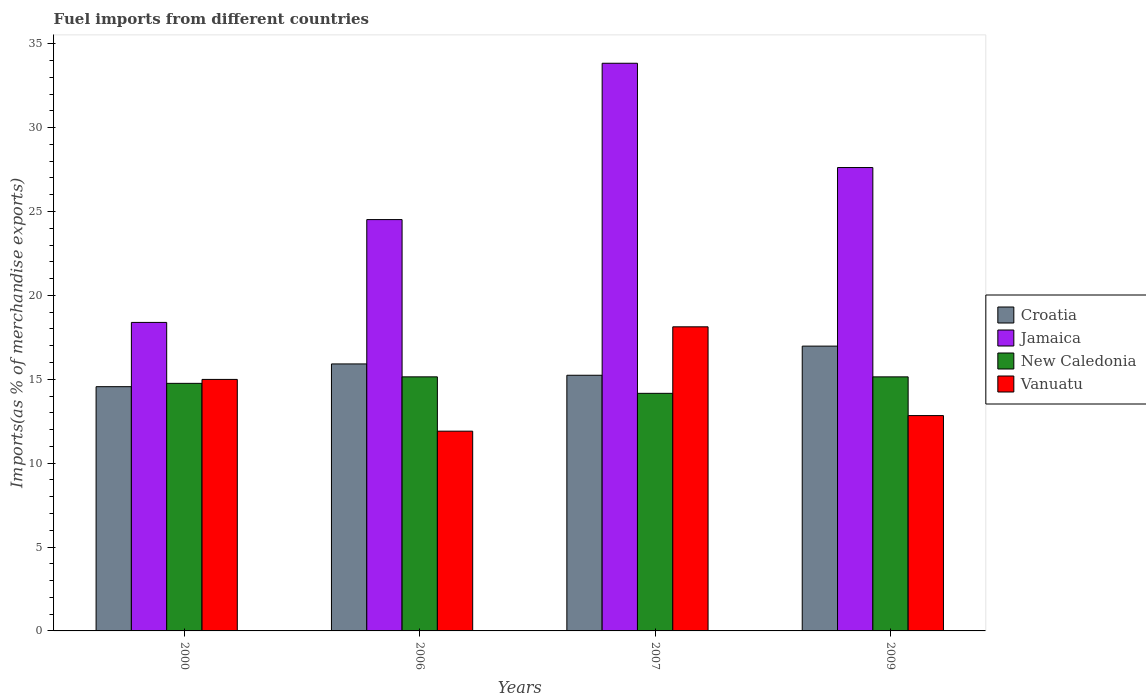How many groups of bars are there?
Provide a short and direct response. 4. Are the number of bars on each tick of the X-axis equal?
Offer a terse response. Yes. How many bars are there on the 2nd tick from the left?
Provide a succinct answer. 4. How many bars are there on the 2nd tick from the right?
Make the answer very short. 4. In how many cases, is the number of bars for a given year not equal to the number of legend labels?
Your answer should be very brief. 0. What is the percentage of imports to different countries in Vanuatu in 2007?
Keep it short and to the point. 18.13. Across all years, what is the maximum percentage of imports to different countries in Croatia?
Make the answer very short. 16.98. Across all years, what is the minimum percentage of imports to different countries in Vanuatu?
Provide a succinct answer. 11.91. In which year was the percentage of imports to different countries in Vanuatu maximum?
Give a very brief answer. 2007. In which year was the percentage of imports to different countries in Vanuatu minimum?
Your answer should be very brief. 2006. What is the total percentage of imports to different countries in Croatia in the graph?
Offer a terse response. 62.69. What is the difference between the percentage of imports to different countries in Jamaica in 2000 and that in 2009?
Provide a succinct answer. -9.23. What is the difference between the percentage of imports to different countries in New Caledonia in 2007 and the percentage of imports to different countries in Vanuatu in 2009?
Your answer should be very brief. 1.33. What is the average percentage of imports to different countries in Croatia per year?
Give a very brief answer. 15.67. In the year 2000, what is the difference between the percentage of imports to different countries in Vanuatu and percentage of imports to different countries in New Caledonia?
Your answer should be compact. 0.23. In how many years, is the percentage of imports to different countries in Jamaica greater than 14 %?
Offer a very short reply. 4. What is the ratio of the percentage of imports to different countries in Vanuatu in 2000 to that in 2009?
Make the answer very short. 1.17. Is the percentage of imports to different countries in Vanuatu in 2000 less than that in 2006?
Offer a very short reply. No. Is the difference between the percentage of imports to different countries in Vanuatu in 2006 and 2007 greater than the difference between the percentage of imports to different countries in New Caledonia in 2006 and 2007?
Offer a terse response. No. What is the difference between the highest and the second highest percentage of imports to different countries in Croatia?
Your response must be concise. 1.06. What is the difference between the highest and the lowest percentage of imports to different countries in New Caledonia?
Your answer should be very brief. 0.98. In how many years, is the percentage of imports to different countries in Jamaica greater than the average percentage of imports to different countries in Jamaica taken over all years?
Provide a short and direct response. 2. Is the sum of the percentage of imports to different countries in New Caledonia in 2000 and 2009 greater than the maximum percentage of imports to different countries in Jamaica across all years?
Your answer should be compact. No. What does the 1st bar from the left in 2000 represents?
Ensure brevity in your answer.  Croatia. What does the 2nd bar from the right in 2007 represents?
Ensure brevity in your answer.  New Caledonia. Is it the case that in every year, the sum of the percentage of imports to different countries in Croatia and percentage of imports to different countries in New Caledonia is greater than the percentage of imports to different countries in Jamaica?
Offer a very short reply. No. How many bars are there?
Keep it short and to the point. 16. Are all the bars in the graph horizontal?
Your answer should be compact. No. Does the graph contain grids?
Your answer should be compact. No. Where does the legend appear in the graph?
Keep it short and to the point. Center right. How many legend labels are there?
Offer a very short reply. 4. What is the title of the graph?
Your response must be concise. Fuel imports from different countries. Does "Gabon" appear as one of the legend labels in the graph?
Keep it short and to the point. No. What is the label or title of the Y-axis?
Ensure brevity in your answer.  Imports(as % of merchandise exports). What is the Imports(as % of merchandise exports) in Croatia in 2000?
Offer a terse response. 14.56. What is the Imports(as % of merchandise exports) in Jamaica in 2000?
Provide a succinct answer. 18.39. What is the Imports(as % of merchandise exports) of New Caledonia in 2000?
Your response must be concise. 14.76. What is the Imports(as % of merchandise exports) of Vanuatu in 2000?
Keep it short and to the point. 14.99. What is the Imports(as % of merchandise exports) in Croatia in 2006?
Provide a short and direct response. 15.92. What is the Imports(as % of merchandise exports) of Jamaica in 2006?
Give a very brief answer. 24.52. What is the Imports(as % of merchandise exports) in New Caledonia in 2006?
Offer a terse response. 15.15. What is the Imports(as % of merchandise exports) of Vanuatu in 2006?
Your answer should be compact. 11.91. What is the Imports(as % of merchandise exports) of Croatia in 2007?
Your answer should be compact. 15.24. What is the Imports(as % of merchandise exports) of Jamaica in 2007?
Provide a short and direct response. 33.84. What is the Imports(as % of merchandise exports) of New Caledonia in 2007?
Provide a succinct answer. 14.16. What is the Imports(as % of merchandise exports) of Vanuatu in 2007?
Provide a short and direct response. 18.13. What is the Imports(as % of merchandise exports) of Croatia in 2009?
Your answer should be very brief. 16.98. What is the Imports(as % of merchandise exports) in Jamaica in 2009?
Provide a short and direct response. 27.62. What is the Imports(as % of merchandise exports) in New Caledonia in 2009?
Your response must be concise. 15.14. What is the Imports(as % of merchandise exports) in Vanuatu in 2009?
Offer a terse response. 12.84. Across all years, what is the maximum Imports(as % of merchandise exports) of Croatia?
Keep it short and to the point. 16.98. Across all years, what is the maximum Imports(as % of merchandise exports) of Jamaica?
Your response must be concise. 33.84. Across all years, what is the maximum Imports(as % of merchandise exports) of New Caledonia?
Provide a short and direct response. 15.15. Across all years, what is the maximum Imports(as % of merchandise exports) of Vanuatu?
Offer a very short reply. 18.13. Across all years, what is the minimum Imports(as % of merchandise exports) in Croatia?
Give a very brief answer. 14.56. Across all years, what is the minimum Imports(as % of merchandise exports) of Jamaica?
Make the answer very short. 18.39. Across all years, what is the minimum Imports(as % of merchandise exports) of New Caledonia?
Offer a very short reply. 14.16. Across all years, what is the minimum Imports(as % of merchandise exports) in Vanuatu?
Your answer should be very brief. 11.91. What is the total Imports(as % of merchandise exports) in Croatia in the graph?
Provide a short and direct response. 62.69. What is the total Imports(as % of merchandise exports) in Jamaica in the graph?
Make the answer very short. 104.37. What is the total Imports(as % of merchandise exports) of New Caledonia in the graph?
Offer a terse response. 59.21. What is the total Imports(as % of merchandise exports) in Vanuatu in the graph?
Make the answer very short. 57.87. What is the difference between the Imports(as % of merchandise exports) in Croatia in 2000 and that in 2006?
Keep it short and to the point. -1.36. What is the difference between the Imports(as % of merchandise exports) in Jamaica in 2000 and that in 2006?
Give a very brief answer. -6.13. What is the difference between the Imports(as % of merchandise exports) of New Caledonia in 2000 and that in 2006?
Provide a succinct answer. -0.39. What is the difference between the Imports(as % of merchandise exports) in Vanuatu in 2000 and that in 2006?
Keep it short and to the point. 3.08. What is the difference between the Imports(as % of merchandise exports) in Croatia in 2000 and that in 2007?
Offer a very short reply. -0.68. What is the difference between the Imports(as % of merchandise exports) in Jamaica in 2000 and that in 2007?
Your response must be concise. -15.45. What is the difference between the Imports(as % of merchandise exports) in New Caledonia in 2000 and that in 2007?
Provide a succinct answer. 0.59. What is the difference between the Imports(as % of merchandise exports) of Vanuatu in 2000 and that in 2007?
Offer a very short reply. -3.14. What is the difference between the Imports(as % of merchandise exports) in Croatia in 2000 and that in 2009?
Make the answer very short. -2.42. What is the difference between the Imports(as % of merchandise exports) of Jamaica in 2000 and that in 2009?
Offer a very short reply. -9.23. What is the difference between the Imports(as % of merchandise exports) in New Caledonia in 2000 and that in 2009?
Your response must be concise. -0.39. What is the difference between the Imports(as % of merchandise exports) in Vanuatu in 2000 and that in 2009?
Offer a very short reply. 2.16. What is the difference between the Imports(as % of merchandise exports) in Croatia in 2006 and that in 2007?
Make the answer very short. 0.68. What is the difference between the Imports(as % of merchandise exports) in Jamaica in 2006 and that in 2007?
Provide a short and direct response. -9.32. What is the difference between the Imports(as % of merchandise exports) in New Caledonia in 2006 and that in 2007?
Your answer should be compact. 0.98. What is the difference between the Imports(as % of merchandise exports) of Vanuatu in 2006 and that in 2007?
Offer a terse response. -6.22. What is the difference between the Imports(as % of merchandise exports) of Croatia in 2006 and that in 2009?
Provide a short and direct response. -1.06. What is the difference between the Imports(as % of merchandise exports) in Jamaica in 2006 and that in 2009?
Make the answer very short. -3.1. What is the difference between the Imports(as % of merchandise exports) in New Caledonia in 2006 and that in 2009?
Provide a short and direct response. 0. What is the difference between the Imports(as % of merchandise exports) of Vanuatu in 2006 and that in 2009?
Keep it short and to the point. -0.93. What is the difference between the Imports(as % of merchandise exports) of Croatia in 2007 and that in 2009?
Ensure brevity in your answer.  -1.74. What is the difference between the Imports(as % of merchandise exports) in Jamaica in 2007 and that in 2009?
Your answer should be very brief. 6.22. What is the difference between the Imports(as % of merchandise exports) in New Caledonia in 2007 and that in 2009?
Offer a terse response. -0.98. What is the difference between the Imports(as % of merchandise exports) of Vanuatu in 2007 and that in 2009?
Make the answer very short. 5.29. What is the difference between the Imports(as % of merchandise exports) in Croatia in 2000 and the Imports(as % of merchandise exports) in Jamaica in 2006?
Provide a short and direct response. -9.96. What is the difference between the Imports(as % of merchandise exports) of Croatia in 2000 and the Imports(as % of merchandise exports) of New Caledonia in 2006?
Your answer should be very brief. -0.59. What is the difference between the Imports(as % of merchandise exports) of Croatia in 2000 and the Imports(as % of merchandise exports) of Vanuatu in 2006?
Ensure brevity in your answer.  2.65. What is the difference between the Imports(as % of merchandise exports) in Jamaica in 2000 and the Imports(as % of merchandise exports) in New Caledonia in 2006?
Keep it short and to the point. 3.25. What is the difference between the Imports(as % of merchandise exports) in Jamaica in 2000 and the Imports(as % of merchandise exports) in Vanuatu in 2006?
Provide a succinct answer. 6.48. What is the difference between the Imports(as % of merchandise exports) in New Caledonia in 2000 and the Imports(as % of merchandise exports) in Vanuatu in 2006?
Offer a very short reply. 2.85. What is the difference between the Imports(as % of merchandise exports) of Croatia in 2000 and the Imports(as % of merchandise exports) of Jamaica in 2007?
Ensure brevity in your answer.  -19.28. What is the difference between the Imports(as % of merchandise exports) of Croatia in 2000 and the Imports(as % of merchandise exports) of New Caledonia in 2007?
Provide a succinct answer. 0.4. What is the difference between the Imports(as % of merchandise exports) of Croatia in 2000 and the Imports(as % of merchandise exports) of Vanuatu in 2007?
Offer a very short reply. -3.57. What is the difference between the Imports(as % of merchandise exports) in Jamaica in 2000 and the Imports(as % of merchandise exports) in New Caledonia in 2007?
Provide a succinct answer. 4.23. What is the difference between the Imports(as % of merchandise exports) in Jamaica in 2000 and the Imports(as % of merchandise exports) in Vanuatu in 2007?
Ensure brevity in your answer.  0.26. What is the difference between the Imports(as % of merchandise exports) in New Caledonia in 2000 and the Imports(as % of merchandise exports) in Vanuatu in 2007?
Your response must be concise. -3.37. What is the difference between the Imports(as % of merchandise exports) in Croatia in 2000 and the Imports(as % of merchandise exports) in Jamaica in 2009?
Offer a very short reply. -13.06. What is the difference between the Imports(as % of merchandise exports) in Croatia in 2000 and the Imports(as % of merchandise exports) in New Caledonia in 2009?
Your response must be concise. -0.59. What is the difference between the Imports(as % of merchandise exports) of Croatia in 2000 and the Imports(as % of merchandise exports) of Vanuatu in 2009?
Your response must be concise. 1.72. What is the difference between the Imports(as % of merchandise exports) of Jamaica in 2000 and the Imports(as % of merchandise exports) of New Caledonia in 2009?
Your answer should be compact. 3.25. What is the difference between the Imports(as % of merchandise exports) in Jamaica in 2000 and the Imports(as % of merchandise exports) in Vanuatu in 2009?
Your answer should be compact. 5.55. What is the difference between the Imports(as % of merchandise exports) of New Caledonia in 2000 and the Imports(as % of merchandise exports) of Vanuatu in 2009?
Offer a terse response. 1.92. What is the difference between the Imports(as % of merchandise exports) of Croatia in 2006 and the Imports(as % of merchandise exports) of Jamaica in 2007?
Your answer should be compact. -17.92. What is the difference between the Imports(as % of merchandise exports) of Croatia in 2006 and the Imports(as % of merchandise exports) of New Caledonia in 2007?
Your answer should be compact. 1.75. What is the difference between the Imports(as % of merchandise exports) in Croatia in 2006 and the Imports(as % of merchandise exports) in Vanuatu in 2007?
Offer a terse response. -2.21. What is the difference between the Imports(as % of merchandise exports) of Jamaica in 2006 and the Imports(as % of merchandise exports) of New Caledonia in 2007?
Your response must be concise. 10.36. What is the difference between the Imports(as % of merchandise exports) in Jamaica in 2006 and the Imports(as % of merchandise exports) in Vanuatu in 2007?
Your answer should be compact. 6.39. What is the difference between the Imports(as % of merchandise exports) of New Caledonia in 2006 and the Imports(as % of merchandise exports) of Vanuatu in 2007?
Offer a terse response. -2.98. What is the difference between the Imports(as % of merchandise exports) of Croatia in 2006 and the Imports(as % of merchandise exports) of Jamaica in 2009?
Offer a very short reply. -11.71. What is the difference between the Imports(as % of merchandise exports) of Croatia in 2006 and the Imports(as % of merchandise exports) of New Caledonia in 2009?
Keep it short and to the point. 0.77. What is the difference between the Imports(as % of merchandise exports) in Croatia in 2006 and the Imports(as % of merchandise exports) in Vanuatu in 2009?
Make the answer very short. 3.08. What is the difference between the Imports(as % of merchandise exports) in Jamaica in 2006 and the Imports(as % of merchandise exports) in New Caledonia in 2009?
Provide a short and direct response. 9.38. What is the difference between the Imports(as % of merchandise exports) of Jamaica in 2006 and the Imports(as % of merchandise exports) of Vanuatu in 2009?
Provide a short and direct response. 11.68. What is the difference between the Imports(as % of merchandise exports) in New Caledonia in 2006 and the Imports(as % of merchandise exports) in Vanuatu in 2009?
Your answer should be very brief. 2.31. What is the difference between the Imports(as % of merchandise exports) of Croatia in 2007 and the Imports(as % of merchandise exports) of Jamaica in 2009?
Provide a succinct answer. -12.38. What is the difference between the Imports(as % of merchandise exports) of Croatia in 2007 and the Imports(as % of merchandise exports) of New Caledonia in 2009?
Offer a very short reply. 0.1. What is the difference between the Imports(as % of merchandise exports) in Croatia in 2007 and the Imports(as % of merchandise exports) in Vanuatu in 2009?
Provide a succinct answer. 2.4. What is the difference between the Imports(as % of merchandise exports) in Jamaica in 2007 and the Imports(as % of merchandise exports) in New Caledonia in 2009?
Provide a short and direct response. 18.7. What is the difference between the Imports(as % of merchandise exports) of Jamaica in 2007 and the Imports(as % of merchandise exports) of Vanuatu in 2009?
Offer a very short reply. 21. What is the difference between the Imports(as % of merchandise exports) of New Caledonia in 2007 and the Imports(as % of merchandise exports) of Vanuatu in 2009?
Keep it short and to the point. 1.33. What is the average Imports(as % of merchandise exports) in Croatia per year?
Offer a very short reply. 15.67. What is the average Imports(as % of merchandise exports) of Jamaica per year?
Your response must be concise. 26.09. What is the average Imports(as % of merchandise exports) in New Caledonia per year?
Offer a very short reply. 14.8. What is the average Imports(as % of merchandise exports) of Vanuatu per year?
Offer a very short reply. 14.47. In the year 2000, what is the difference between the Imports(as % of merchandise exports) in Croatia and Imports(as % of merchandise exports) in Jamaica?
Provide a short and direct response. -3.83. In the year 2000, what is the difference between the Imports(as % of merchandise exports) in Croatia and Imports(as % of merchandise exports) in New Caledonia?
Your answer should be very brief. -0.2. In the year 2000, what is the difference between the Imports(as % of merchandise exports) in Croatia and Imports(as % of merchandise exports) in Vanuatu?
Your answer should be very brief. -0.43. In the year 2000, what is the difference between the Imports(as % of merchandise exports) of Jamaica and Imports(as % of merchandise exports) of New Caledonia?
Give a very brief answer. 3.63. In the year 2000, what is the difference between the Imports(as % of merchandise exports) of Jamaica and Imports(as % of merchandise exports) of Vanuatu?
Your answer should be compact. 3.4. In the year 2000, what is the difference between the Imports(as % of merchandise exports) of New Caledonia and Imports(as % of merchandise exports) of Vanuatu?
Make the answer very short. -0.23. In the year 2006, what is the difference between the Imports(as % of merchandise exports) of Croatia and Imports(as % of merchandise exports) of Jamaica?
Ensure brevity in your answer.  -8.6. In the year 2006, what is the difference between the Imports(as % of merchandise exports) of Croatia and Imports(as % of merchandise exports) of New Caledonia?
Your response must be concise. 0.77. In the year 2006, what is the difference between the Imports(as % of merchandise exports) of Croatia and Imports(as % of merchandise exports) of Vanuatu?
Offer a very short reply. 4.01. In the year 2006, what is the difference between the Imports(as % of merchandise exports) of Jamaica and Imports(as % of merchandise exports) of New Caledonia?
Keep it short and to the point. 9.38. In the year 2006, what is the difference between the Imports(as % of merchandise exports) of Jamaica and Imports(as % of merchandise exports) of Vanuatu?
Offer a very short reply. 12.61. In the year 2006, what is the difference between the Imports(as % of merchandise exports) of New Caledonia and Imports(as % of merchandise exports) of Vanuatu?
Provide a short and direct response. 3.24. In the year 2007, what is the difference between the Imports(as % of merchandise exports) in Croatia and Imports(as % of merchandise exports) in Jamaica?
Make the answer very short. -18.6. In the year 2007, what is the difference between the Imports(as % of merchandise exports) of Croatia and Imports(as % of merchandise exports) of New Caledonia?
Offer a very short reply. 1.08. In the year 2007, what is the difference between the Imports(as % of merchandise exports) in Croatia and Imports(as % of merchandise exports) in Vanuatu?
Your answer should be very brief. -2.89. In the year 2007, what is the difference between the Imports(as % of merchandise exports) in Jamaica and Imports(as % of merchandise exports) in New Caledonia?
Your response must be concise. 19.68. In the year 2007, what is the difference between the Imports(as % of merchandise exports) of Jamaica and Imports(as % of merchandise exports) of Vanuatu?
Give a very brief answer. 15.71. In the year 2007, what is the difference between the Imports(as % of merchandise exports) in New Caledonia and Imports(as % of merchandise exports) in Vanuatu?
Your answer should be very brief. -3.97. In the year 2009, what is the difference between the Imports(as % of merchandise exports) of Croatia and Imports(as % of merchandise exports) of Jamaica?
Your answer should be very brief. -10.65. In the year 2009, what is the difference between the Imports(as % of merchandise exports) in Croatia and Imports(as % of merchandise exports) in New Caledonia?
Provide a succinct answer. 1.83. In the year 2009, what is the difference between the Imports(as % of merchandise exports) in Croatia and Imports(as % of merchandise exports) in Vanuatu?
Give a very brief answer. 4.14. In the year 2009, what is the difference between the Imports(as % of merchandise exports) of Jamaica and Imports(as % of merchandise exports) of New Caledonia?
Provide a succinct answer. 12.48. In the year 2009, what is the difference between the Imports(as % of merchandise exports) of Jamaica and Imports(as % of merchandise exports) of Vanuatu?
Give a very brief answer. 14.79. In the year 2009, what is the difference between the Imports(as % of merchandise exports) in New Caledonia and Imports(as % of merchandise exports) in Vanuatu?
Keep it short and to the point. 2.31. What is the ratio of the Imports(as % of merchandise exports) in Croatia in 2000 to that in 2006?
Keep it short and to the point. 0.91. What is the ratio of the Imports(as % of merchandise exports) of New Caledonia in 2000 to that in 2006?
Offer a very short reply. 0.97. What is the ratio of the Imports(as % of merchandise exports) of Vanuatu in 2000 to that in 2006?
Your answer should be compact. 1.26. What is the ratio of the Imports(as % of merchandise exports) of Croatia in 2000 to that in 2007?
Offer a very short reply. 0.96. What is the ratio of the Imports(as % of merchandise exports) of Jamaica in 2000 to that in 2007?
Ensure brevity in your answer.  0.54. What is the ratio of the Imports(as % of merchandise exports) of New Caledonia in 2000 to that in 2007?
Your answer should be compact. 1.04. What is the ratio of the Imports(as % of merchandise exports) of Vanuatu in 2000 to that in 2007?
Your response must be concise. 0.83. What is the ratio of the Imports(as % of merchandise exports) of Croatia in 2000 to that in 2009?
Your answer should be very brief. 0.86. What is the ratio of the Imports(as % of merchandise exports) of Jamaica in 2000 to that in 2009?
Offer a terse response. 0.67. What is the ratio of the Imports(as % of merchandise exports) in New Caledonia in 2000 to that in 2009?
Offer a terse response. 0.97. What is the ratio of the Imports(as % of merchandise exports) in Vanuatu in 2000 to that in 2009?
Give a very brief answer. 1.17. What is the ratio of the Imports(as % of merchandise exports) in Croatia in 2006 to that in 2007?
Make the answer very short. 1.04. What is the ratio of the Imports(as % of merchandise exports) of Jamaica in 2006 to that in 2007?
Your answer should be compact. 0.72. What is the ratio of the Imports(as % of merchandise exports) of New Caledonia in 2006 to that in 2007?
Your answer should be very brief. 1.07. What is the ratio of the Imports(as % of merchandise exports) in Vanuatu in 2006 to that in 2007?
Make the answer very short. 0.66. What is the ratio of the Imports(as % of merchandise exports) in Jamaica in 2006 to that in 2009?
Give a very brief answer. 0.89. What is the ratio of the Imports(as % of merchandise exports) in Vanuatu in 2006 to that in 2009?
Give a very brief answer. 0.93. What is the ratio of the Imports(as % of merchandise exports) of Croatia in 2007 to that in 2009?
Your answer should be compact. 0.9. What is the ratio of the Imports(as % of merchandise exports) of Jamaica in 2007 to that in 2009?
Make the answer very short. 1.23. What is the ratio of the Imports(as % of merchandise exports) of New Caledonia in 2007 to that in 2009?
Provide a short and direct response. 0.94. What is the ratio of the Imports(as % of merchandise exports) of Vanuatu in 2007 to that in 2009?
Offer a terse response. 1.41. What is the difference between the highest and the second highest Imports(as % of merchandise exports) in Croatia?
Your response must be concise. 1.06. What is the difference between the highest and the second highest Imports(as % of merchandise exports) of Jamaica?
Provide a short and direct response. 6.22. What is the difference between the highest and the second highest Imports(as % of merchandise exports) of New Caledonia?
Make the answer very short. 0. What is the difference between the highest and the second highest Imports(as % of merchandise exports) of Vanuatu?
Offer a terse response. 3.14. What is the difference between the highest and the lowest Imports(as % of merchandise exports) of Croatia?
Your answer should be very brief. 2.42. What is the difference between the highest and the lowest Imports(as % of merchandise exports) in Jamaica?
Ensure brevity in your answer.  15.45. What is the difference between the highest and the lowest Imports(as % of merchandise exports) in New Caledonia?
Provide a short and direct response. 0.98. What is the difference between the highest and the lowest Imports(as % of merchandise exports) of Vanuatu?
Provide a succinct answer. 6.22. 